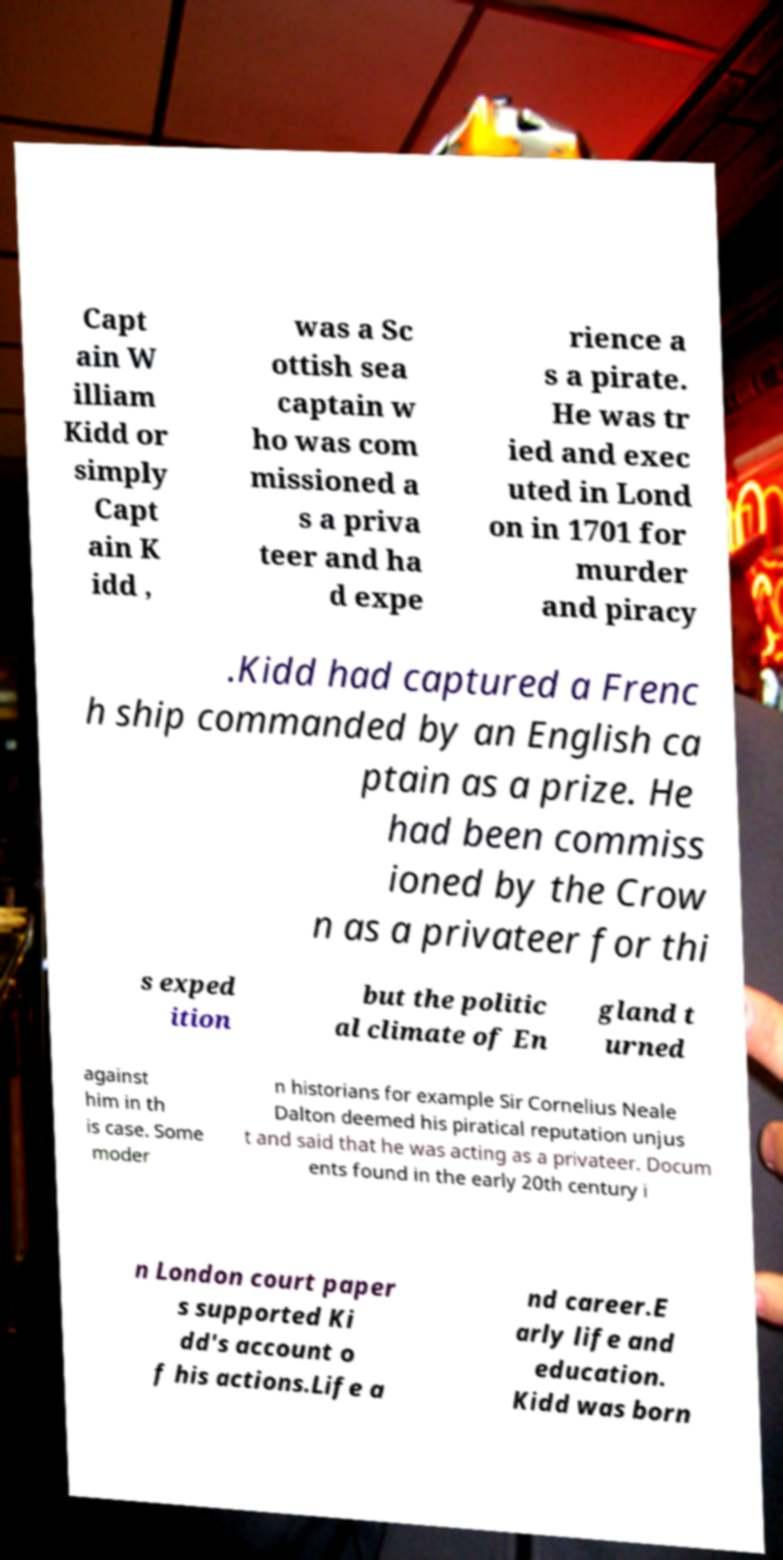Could you extract and type out the text from this image? Capt ain W illiam Kidd or simply Capt ain K idd , was a Sc ottish sea captain w ho was com missioned a s a priva teer and ha d expe rience a s a pirate. He was tr ied and exec uted in Lond on in 1701 for murder and piracy .Kidd had captured a Frenc h ship commanded by an English ca ptain as a prize. He had been commiss ioned by the Crow n as a privateer for thi s exped ition but the politic al climate of En gland t urned against him in th is case. Some moder n historians for example Sir Cornelius Neale Dalton deemed his piratical reputation unjus t and said that he was acting as a privateer. Docum ents found in the early 20th century i n London court paper s supported Ki dd's account o f his actions.Life a nd career.E arly life and education. Kidd was born 